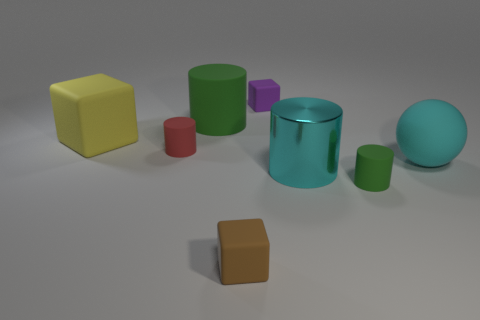Add 1 small rubber objects. How many objects exist? 9 Subtract all spheres. How many objects are left? 7 Subtract all big cyan matte spheres. Subtract all purple rubber blocks. How many objects are left? 6 Add 4 purple objects. How many purple objects are left? 5 Add 2 small green cylinders. How many small green cylinders exist? 3 Subtract 2 green cylinders. How many objects are left? 6 